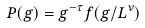<formula> <loc_0><loc_0><loc_500><loc_500>P ( g ) = g ^ { - \tau } f ( g / L ^ { \nu } )</formula> 